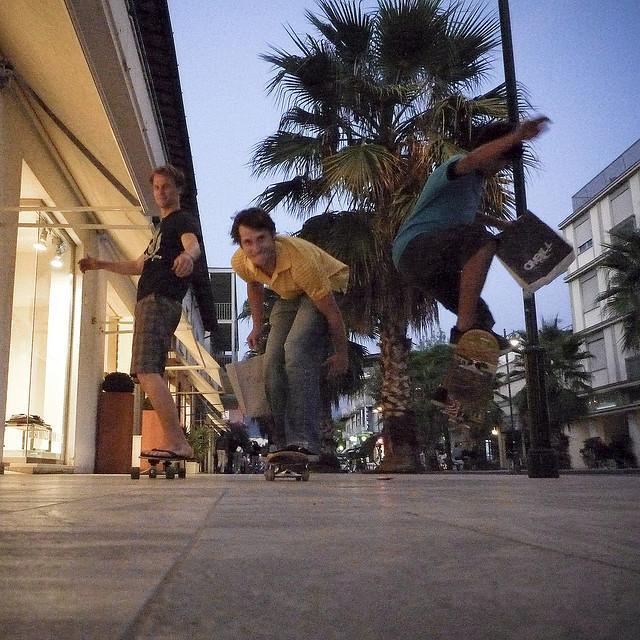How many people are there?
Give a very brief answer. 3. 